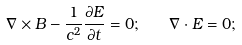<formula> <loc_0><loc_0><loc_500><loc_500>\nabla \times B - \frac { 1 } { c ^ { 2 } } \frac { \partial E } { \partial t } = 0 ; \quad \nabla \cdot E = 0 ;</formula> 